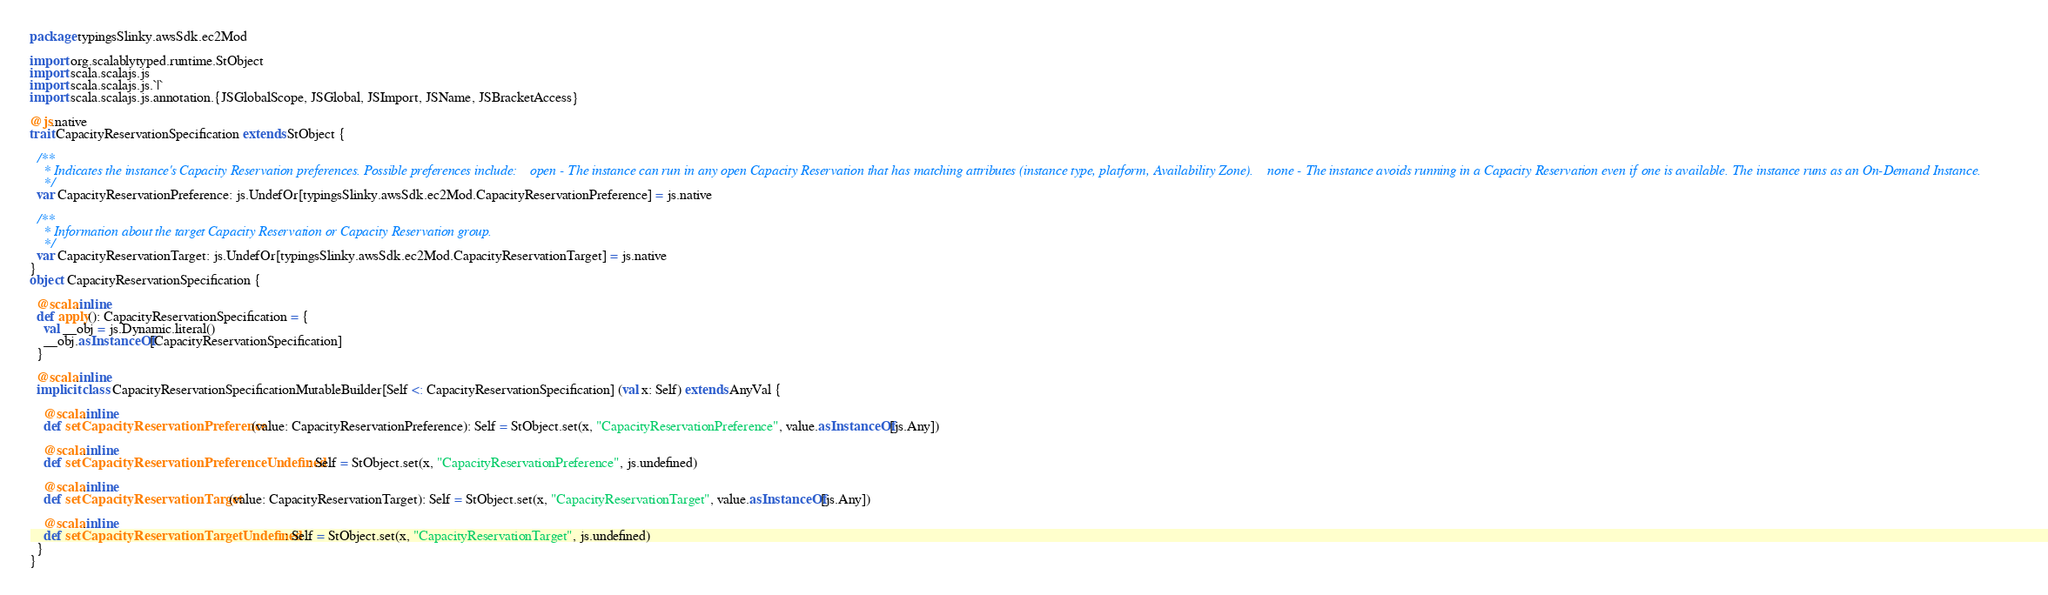Convert code to text. <code><loc_0><loc_0><loc_500><loc_500><_Scala_>package typingsSlinky.awsSdk.ec2Mod

import org.scalablytyped.runtime.StObject
import scala.scalajs.js
import scala.scalajs.js.`|`
import scala.scalajs.js.annotation.{JSGlobalScope, JSGlobal, JSImport, JSName, JSBracketAccess}

@js.native
trait CapacityReservationSpecification extends StObject {
  
  /**
    * Indicates the instance's Capacity Reservation preferences. Possible preferences include:    open - The instance can run in any open Capacity Reservation that has matching attributes (instance type, platform, Availability Zone).    none - The instance avoids running in a Capacity Reservation even if one is available. The instance runs as an On-Demand Instance.  
    */
  var CapacityReservationPreference: js.UndefOr[typingsSlinky.awsSdk.ec2Mod.CapacityReservationPreference] = js.native
  
  /**
    * Information about the target Capacity Reservation or Capacity Reservation group.
    */
  var CapacityReservationTarget: js.UndefOr[typingsSlinky.awsSdk.ec2Mod.CapacityReservationTarget] = js.native
}
object CapacityReservationSpecification {
  
  @scala.inline
  def apply(): CapacityReservationSpecification = {
    val __obj = js.Dynamic.literal()
    __obj.asInstanceOf[CapacityReservationSpecification]
  }
  
  @scala.inline
  implicit class CapacityReservationSpecificationMutableBuilder[Self <: CapacityReservationSpecification] (val x: Self) extends AnyVal {
    
    @scala.inline
    def setCapacityReservationPreference(value: CapacityReservationPreference): Self = StObject.set(x, "CapacityReservationPreference", value.asInstanceOf[js.Any])
    
    @scala.inline
    def setCapacityReservationPreferenceUndefined: Self = StObject.set(x, "CapacityReservationPreference", js.undefined)
    
    @scala.inline
    def setCapacityReservationTarget(value: CapacityReservationTarget): Self = StObject.set(x, "CapacityReservationTarget", value.asInstanceOf[js.Any])
    
    @scala.inline
    def setCapacityReservationTargetUndefined: Self = StObject.set(x, "CapacityReservationTarget", js.undefined)
  }
}
</code> 